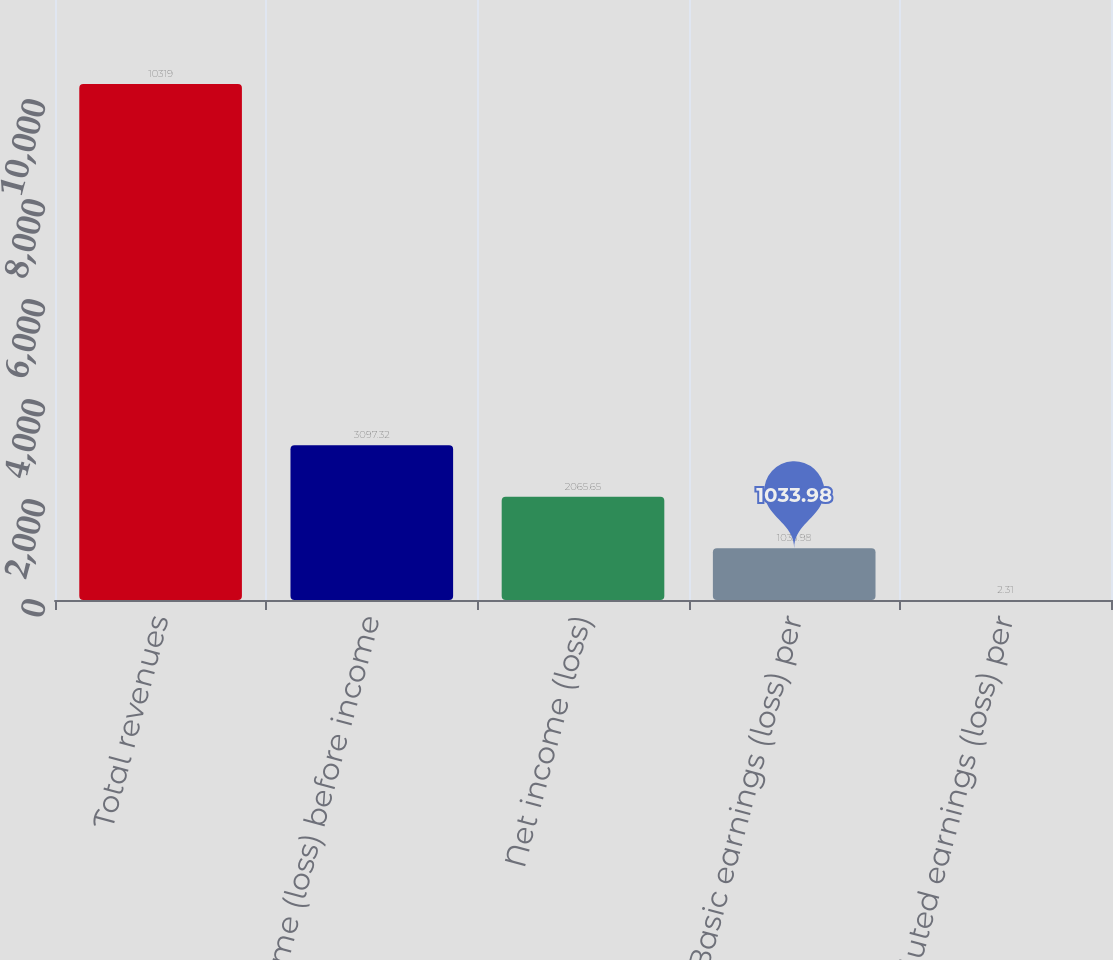Convert chart to OTSL. <chart><loc_0><loc_0><loc_500><loc_500><bar_chart><fcel>Total revenues<fcel>Income (loss) before income<fcel>Net income (loss)<fcel>Basic earnings (loss) per<fcel>Diluted earnings (loss) per<nl><fcel>10319<fcel>3097.32<fcel>2065.65<fcel>1033.98<fcel>2.31<nl></chart> 